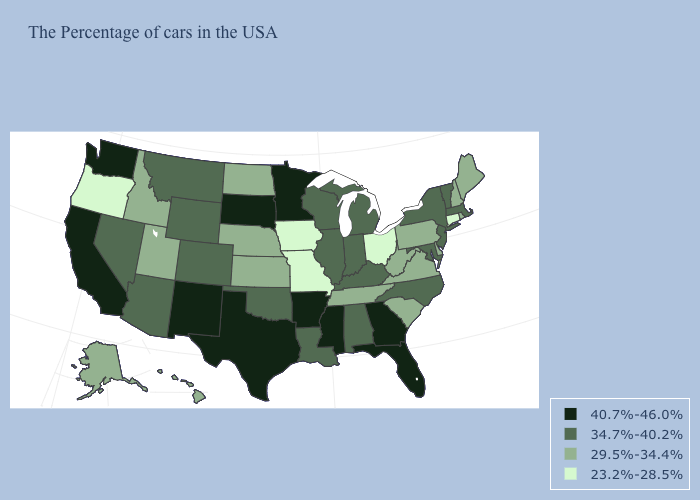How many symbols are there in the legend?
Keep it brief. 4. What is the value of Washington?
Short answer required. 40.7%-46.0%. What is the highest value in the USA?
Answer briefly. 40.7%-46.0%. What is the value of Florida?
Answer briefly. 40.7%-46.0%. What is the lowest value in the MidWest?
Answer briefly. 23.2%-28.5%. What is the value of Idaho?
Keep it brief. 29.5%-34.4%. Does North Carolina have the highest value in the South?
Concise answer only. No. Does the first symbol in the legend represent the smallest category?
Give a very brief answer. No. Does Oregon have the lowest value in the USA?
Write a very short answer. Yes. Which states hav the highest value in the Northeast?
Keep it brief. Massachusetts, Vermont, New York, New Jersey. What is the value of South Dakota?
Short answer required. 40.7%-46.0%. Does the map have missing data?
Write a very short answer. No. Name the states that have a value in the range 29.5%-34.4%?
Concise answer only. Maine, Rhode Island, New Hampshire, Delaware, Pennsylvania, Virginia, South Carolina, West Virginia, Tennessee, Kansas, Nebraska, North Dakota, Utah, Idaho, Alaska, Hawaii. Among the states that border Connecticut , which have the lowest value?
Be succinct. Rhode Island. Which states have the lowest value in the USA?
Write a very short answer. Connecticut, Ohio, Missouri, Iowa, Oregon. 